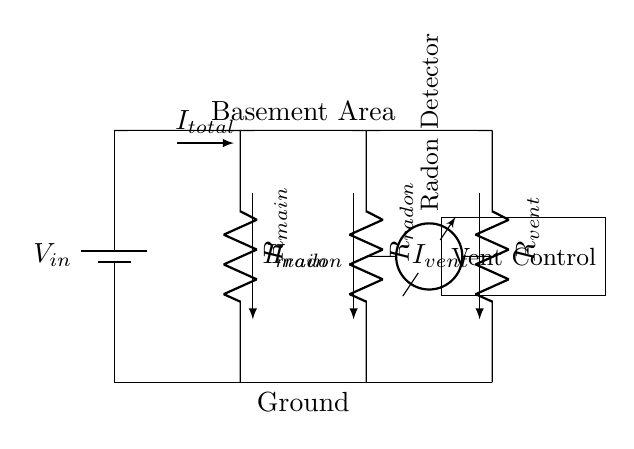What is the total current entering the circuit? The total current entering the circuit is labeled as I total, which represents the sum of current flowing through the main branch and the parallel branches.
Answer: I total What do the parallel branches represent in this circuit? The parallel branches consist of the radon detector and the ventilation control, indicating separate pathways for the current to flow while monitoring and controlling radon levels.
Answer: Radon detector and ventilation control What is the function of R main in the circuit? R main serves as the main resistance that limits the overall current flowing in the circuit before it divides into the parallel branches, impacting the total current calculation.
Answer: Main resistance In what direction does the current I radon flow? The current I radon flows from the power source through the R radon resistance and then back to the ground, fitting into the path established by the parallel configuration of the circuit.
Answer: From power source to ground How does the current divide between R radon and R vent? The current divides according to the resistance values of R radon and R vent, following Ohm's Law where a lower resistance branch receives a higher portion of the total current.
Answer: Based on resistance values What are the two components connected in parallel with R main? The two components are the radon detector (R radon) and the ventilation control (R vent), both receiving current from the main branch in a parallel arrangement.
Answer: Radon detector and ventilation control What is the relationship between R radon and R vent in terms of current distribution? The relationship is that the current distribution between R radon and R vent is inversely proportional to their resistances; a smaller resistance receives more current, dividing the total current in the circuit accordingly.
Answer: Inversely proportional 